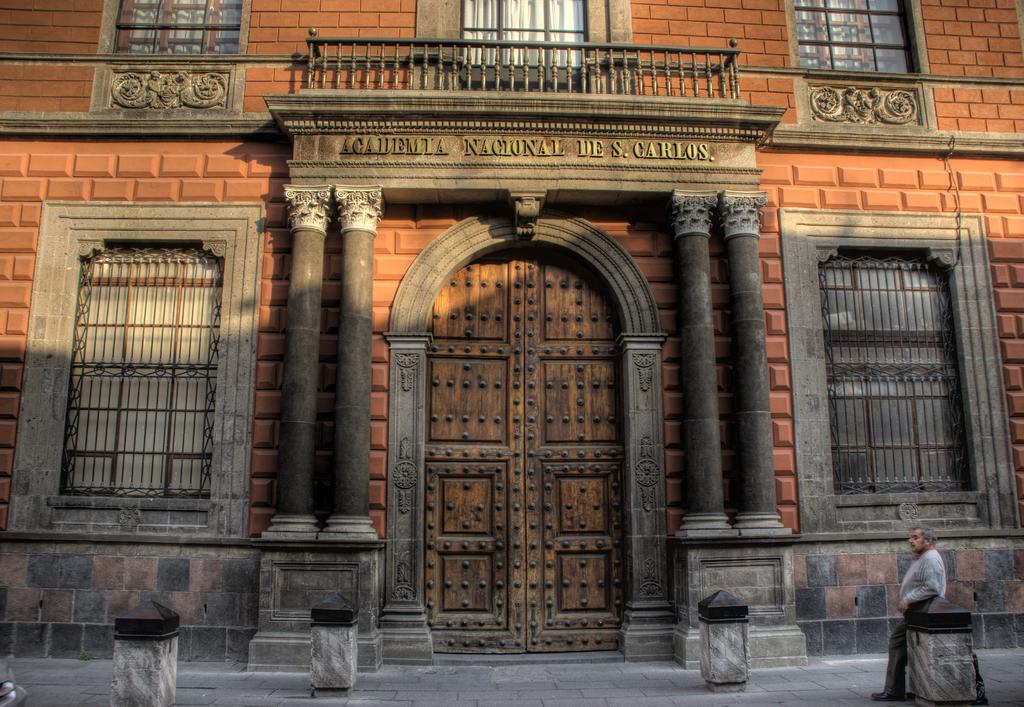What is present in the image? There is a person, a building, a door, and windows in the image. Can you describe the person in the image? The provided facts do not give any details about the person's appearance or characteristics. What is the purpose of the door in the image? The door in the image is likely used for entering or exiting the building. How many windows are visible in the image? The provided facts do not specify the number of windows in the image. What type of hair can be seen on the person in the image? The provided facts do not give any details about the person's appearance or characteristics, including their hair. Is there a camera visible in the image? There is no mention of a camera in the provided facts, so it cannot be determined if one is present in the image. 